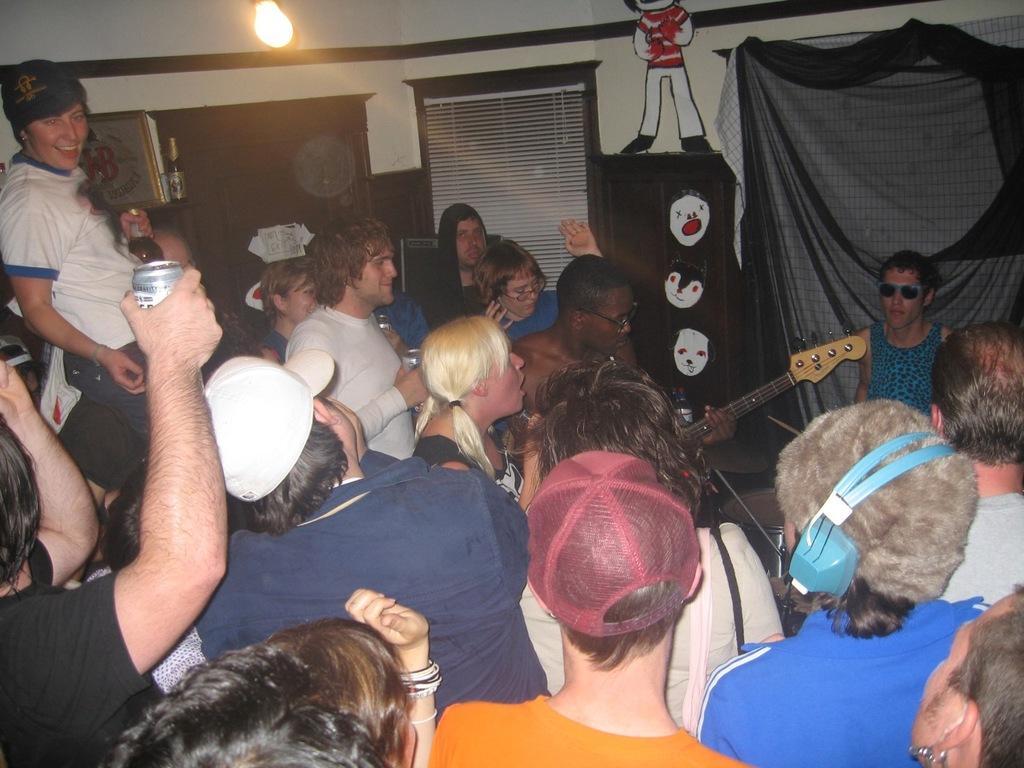Could you give a brief overview of what you see in this image? This image is taken indoors. In the background there is a wall with a door, a window blind and there is a picture frame on the wall. There are a few curtains. There are a few stickers on the wall. At the top of the image there is a light. In the middle of the image there are many people, a few are holding coke tins in their hands and a man is holding a guitar in his hands. 